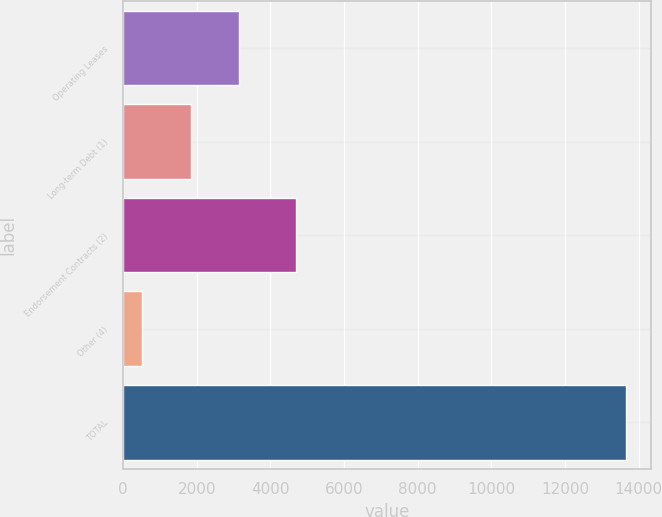Convert chart. <chart><loc_0><loc_0><loc_500><loc_500><bar_chart><fcel>Operating Leases<fcel>Long-term Debt (1)<fcel>Endorsement Contracts (2)<fcel>Other (4)<fcel>TOTAL<nl><fcel>3163.1<fcel>1851<fcel>4704<fcel>517<fcel>13638<nl></chart> 